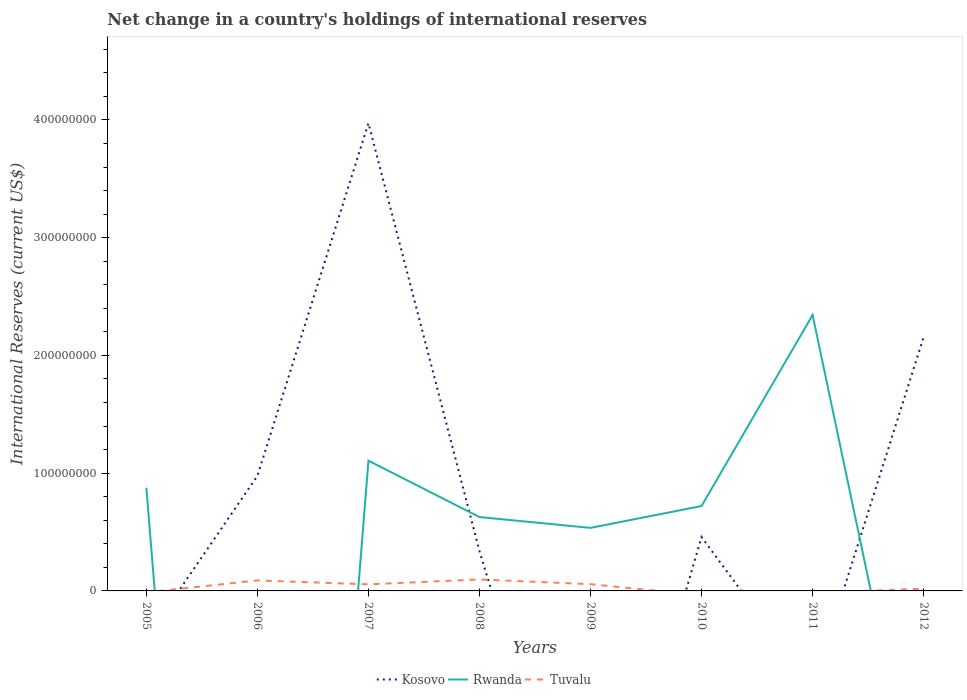Is the number of lines equal to the number of legend labels?
Provide a short and direct response. No. Across all years, what is the maximum international reserves in Kosovo?
Give a very brief answer. 0. What is the total international reserves in Rwanda in the graph?
Your response must be concise. -1.81e+08. What is the difference between the highest and the second highest international reserves in Kosovo?
Your response must be concise. 3.97e+08. What is the difference between the highest and the lowest international reserves in Kosovo?
Ensure brevity in your answer.  2. Is the international reserves in Tuvalu strictly greater than the international reserves in Rwanda over the years?
Offer a very short reply. No. How many years are there in the graph?
Offer a terse response. 8. What is the difference between two consecutive major ticks on the Y-axis?
Provide a short and direct response. 1.00e+08. Are the values on the major ticks of Y-axis written in scientific E-notation?
Offer a terse response. No. How many legend labels are there?
Offer a very short reply. 3. How are the legend labels stacked?
Your answer should be compact. Horizontal. What is the title of the graph?
Your answer should be compact. Net change in a country's holdings of international reserves. What is the label or title of the Y-axis?
Give a very brief answer. International Reserves (current US$). What is the International Reserves (current US$) in Rwanda in 2005?
Your answer should be compact. 8.77e+07. What is the International Reserves (current US$) in Tuvalu in 2005?
Your answer should be compact. 0. What is the International Reserves (current US$) in Kosovo in 2006?
Ensure brevity in your answer.  9.77e+07. What is the International Reserves (current US$) in Tuvalu in 2006?
Provide a succinct answer. 8.93e+06. What is the International Reserves (current US$) of Kosovo in 2007?
Offer a terse response. 3.97e+08. What is the International Reserves (current US$) of Rwanda in 2007?
Provide a short and direct response. 1.11e+08. What is the International Reserves (current US$) in Tuvalu in 2007?
Provide a succinct answer. 5.58e+06. What is the International Reserves (current US$) in Kosovo in 2008?
Give a very brief answer. 3.38e+07. What is the International Reserves (current US$) in Rwanda in 2008?
Provide a succinct answer. 6.27e+07. What is the International Reserves (current US$) of Tuvalu in 2008?
Your answer should be very brief. 9.75e+06. What is the International Reserves (current US$) of Rwanda in 2009?
Give a very brief answer. 5.35e+07. What is the International Reserves (current US$) of Tuvalu in 2009?
Offer a terse response. 5.74e+06. What is the International Reserves (current US$) of Kosovo in 2010?
Keep it short and to the point. 4.57e+07. What is the International Reserves (current US$) in Rwanda in 2010?
Make the answer very short. 7.21e+07. What is the International Reserves (current US$) in Kosovo in 2011?
Provide a succinct answer. 0. What is the International Reserves (current US$) of Rwanda in 2011?
Keep it short and to the point. 2.34e+08. What is the International Reserves (current US$) of Tuvalu in 2011?
Keep it short and to the point. 0. What is the International Reserves (current US$) in Kosovo in 2012?
Provide a succinct answer. 2.16e+08. What is the International Reserves (current US$) of Tuvalu in 2012?
Give a very brief answer. 1.95e+06. Across all years, what is the maximum International Reserves (current US$) of Kosovo?
Provide a short and direct response. 3.97e+08. Across all years, what is the maximum International Reserves (current US$) of Rwanda?
Make the answer very short. 2.34e+08. Across all years, what is the maximum International Reserves (current US$) of Tuvalu?
Your answer should be very brief. 9.75e+06. Across all years, what is the minimum International Reserves (current US$) of Kosovo?
Keep it short and to the point. 0. What is the total International Reserves (current US$) of Kosovo in the graph?
Ensure brevity in your answer.  7.90e+08. What is the total International Reserves (current US$) in Rwanda in the graph?
Keep it short and to the point. 6.21e+08. What is the total International Reserves (current US$) in Tuvalu in the graph?
Give a very brief answer. 3.19e+07. What is the difference between the International Reserves (current US$) in Rwanda in 2005 and that in 2007?
Keep it short and to the point. -2.29e+07. What is the difference between the International Reserves (current US$) of Rwanda in 2005 and that in 2008?
Provide a succinct answer. 2.50e+07. What is the difference between the International Reserves (current US$) in Rwanda in 2005 and that in 2009?
Provide a succinct answer. 3.41e+07. What is the difference between the International Reserves (current US$) of Rwanda in 2005 and that in 2010?
Offer a very short reply. 1.56e+07. What is the difference between the International Reserves (current US$) in Rwanda in 2005 and that in 2011?
Ensure brevity in your answer.  -1.47e+08. What is the difference between the International Reserves (current US$) of Kosovo in 2006 and that in 2007?
Your response must be concise. -3.00e+08. What is the difference between the International Reserves (current US$) of Tuvalu in 2006 and that in 2007?
Provide a succinct answer. 3.34e+06. What is the difference between the International Reserves (current US$) of Kosovo in 2006 and that in 2008?
Your answer should be compact. 6.39e+07. What is the difference between the International Reserves (current US$) in Tuvalu in 2006 and that in 2008?
Provide a short and direct response. -8.27e+05. What is the difference between the International Reserves (current US$) of Tuvalu in 2006 and that in 2009?
Your answer should be very brief. 3.19e+06. What is the difference between the International Reserves (current US$) of Kosovo in 2006 and that in 2010?
Offer a very short reply. 5.20e+07. What is the difference between the International Reserves (current US$) of Kosovo in 2006 and that in 2012?
Your answer should be compact. -1.18e+08. What is the difference between the International Reserves (current US$) in Tuvalu in 2006 and that in 2012?
Provide a short and direct response. 6.97e+06. What is the difference between the International Reserves (current US$) in Kosovo in 2007 and that in 2008?
Offer a very short reply. 3.63e+08. What is the difference between the International Reserves (current US$) of Rwanda in 2007 and that in 2008?
Offer a very short reply. 4.79e+07. What is the difference between the International Reserves (current US$) in Tuvalu in 2007 and that in 2008?
Give a very brief answer. -4.17e+06. What is the difference between the International Reserves (current US$) of Rwanda in 2007 and that in 2009?
Provide a short and direct response. 5.71e+07. What is the difference between the International Reserves (current US$) in Tuvalu in 2007 and that in 2009?
Give a very brief answer. -1.52e+05. What is the difference between the International Reserves (current US$) in Kosovo in 2007 and that in 2010?
Your response must be concise. 3.52e+08. What is the difference between the International Reserves (current US$) of Rwanda in 2007 and that in 2010?
Make the answer very short. 3.85e+07. What is the difference between the International Reserves (current US$) of Rwanda in 2007 and that in 2011?
Keep it short and to the point. -1.24e+08. What is the difference between the International Reserves (current US$) in Kosovo in 2007 and that in 2012?
Provide a succinct answer. 1.82e+08. What is the difference between the International Reserves (current US$) of Tuvalu in 2007 and that in 2012?
Provide a succinct answer. 3.63e+06. What is the difference between the International Reserves (current US$) in Rwanda in 2008 and that in 2009?
Offer a terse response. 9.17e+06. What is the difference between the International Reserves (current US$) of Tuvalu in 2008 and that in 2009?
Make the answer very short. 4.02e+06. What is the difference between the International Reserves (current US$) of Kosovo in 2008 and that in 2010?
Give a very brief answer. -1.19e+07. What is the difference between the International Reserves (current US$) of Rwanda in 2008 and that in 2010?
Provide a short and direct response. -9.38e+06. What is the difference between the International Reserves (current US$) in Rwanda in 2008 and that in 2011?
Offer a very short reply. -1.72e+08. What is the difference between the International Reserves (current US$) in Kosovo in 2008 and that in 2012?
Your answer should be compact. -1.82e+08. What is the difference between the International Reserves (current US$) of Tuvalu in 2008 and that in 2012?
Your response must be concise. 7.80e+06. What is the difference between the International Reserves (current US$) in Rwanda in 2009 and that in 2010?
Your answer should be compact. -1.85e+07. What is the difference between the International Reserves (current US$) of Rwanda in 2009 and that in 2011?
Give a very brief answer. -1.81e+08. What is the difference between the International Reserves (current US$) of Tuvalu in 2009 and that in 2012?
Your answer should be very brief. 3.79e+06. What is the difference between the International Reserves (current US$) of Rwanda in 2010 and that in 2011?
Ensure brevity in your answer.  -1.62e+08. What is the difference between the International Reserves (current US$) in Kosovo in 2010 and that in 2012?
Your answer should be compact. -1.70e+08. What is the difference between the International Reserves (current US$) in Rwanda in 2005 and the International Reserves (current US$) in Tuvalu in 2006?
Provide a succinct answer. 7.88e+07. What is the difference between the International Reserves (current US$) in Rwanda in 2005 and the International Reserves (current US$) in Tuvalu in 2007?
Your response must be concise. 8.21e+07. What is the difference between the International Reserves (current US$) of Rwanda in 2005 and the International Reserves (current US$) of Tuvalu in 2008?
Give a very brief answer. 7.79e+07. What is the difference between the International Reserves (current US$) of Rwanda in 2005 and the International Reserves (current US$) of Tuvalu in 2009?
Provide a succinct answer. 8.19e+07. What is the difference between the International Reserves (current US$) of Rwanda in 2005 and the International Reserves (current US$) of Tuvalu in 2012?
Ensure brevity in your answer.  8.57e+07. What is the difference between the International Reserves (current US$) of Kosovo in 2006 and the International Reserves (current US$) of Rwanda in 2007?
Give a very brief answer. -1.29e+07. What is the difference between the International Reserves (current US$) of Kosovo in 2006 and the International Reserves (current US$) of Tuvalu in 2007?
Your answer should be very brief. 9.21e+07. What is the difference between the International Reserves (current US$) of Kosovo in 2006 and the International Reserves (current US$) of Rwanda in 2008?
Your response must be concise. 3.50e+07. What is the difference between the International Reserves (current US$) in Kosovo in 2006 and the International Reserves (current US$) in Tuvalu in 2008?
Ensure brevity in your answer.  8.79e+07. What is the difference between the International Reserves (current US$) of Kosovo in 2006 and the International Reserves (current US$) of Rwanda in 2009?
Ensure brevity in your answer.  4.41e+07. What is the difference between the International Reserves (current US$) of Kosovo in 2006 and the International Reserves (current US$) of Tuvalu in 2009?
Your answer should be very brief. 9.20e+07. What is the difference between the International Reserves (current US$) in Kosovo in 2006 and the International Reserves (current US$) in Rwanda in 2010?
Make the answer very short. 2.56e+07. What is the difference between the International Reserves (current US$) of Kosovo in 2006 and the International Reserves (current US$) of Rwanda in 2011?
Offer a terse response. -1.37e+08. What is the difference between the International Reserves (current US$) of Kosovo in 2006 and the International Reserves (current US$) of Tuvalu in 2012?
Ensure brevity in your answer.  9.57e+07. What is the difference between the International Reserves (current US$) of Kosovo in 2007 and the International Reserves (current US$) of Rwanda in 2008?
Provide a short and direct response. 3.35e+08. What is the difference between the International Reserves (current US$) in Kosovo in 2007 and the International Reserves (current US$) in Tuvalu in 2008?
Keep it short and to the point. 3.88e+08. What is the difference between the International Reserves (current US$) in Rwanda in 2007 and the International Reserves (current US$) in Tuvalu in 2008?
Your answer should be very brief. 1.01e+08. What is the difference between the International Reserves (current US$) of Kosovo in 2007 and the International Reserves (current US$) of Rwanda in 2009?
Make the answer very short. 3.44e+08. What is the difference between the International Reserves (current US$) of Kosovo in 2007 and the International Reserves (current US$) of Tuvalu in 2009?
Your answer should be very brief. 3.92e+08. What is the difference between the International Reserves (current US$) in Rwanda in 2007 and the International Reserves (current US$) in Tuvalu in 2009?
Offer a terse response. 1.05e+08. What is the difference between the International Reserves (current US$) in Kosovo in 2007 and the International Reserves (current US$) in Rwanda in 2010?
Your response must be concise. 3.25e+08. What is the difference between the International Reserves (current US$) of Kosovo in 2007 and the International Reserves (current US$) of Rwanda in 2011?
Offer a terse response. 1.63e+08. What is the difference between the International Reserves (current US$) of Kosovo in 2007 and the International Reserves (current US$) of Tuvalu in 2012?
Your answer should be very brief. 3.95e+08. What is the difference between the International Reserves (current US$) of Rwanda in 2007 and the International Reserves (current US$) of Tuvalu in 2012?
Make the answer very short. 1.09e+08. What is the difference between the International Reserves (current US$) of Kosovo in 2008 and the International Reserves (current US$) of Rwanda in 2009?
Ensure brevity in your answer.  -1.97e+07. What is the difference between the International Reserves (current US$) in Kosovo in 2008 and the International Reserves (current US$) in Tuvalu in 2009?
Provide a short and direct response. 2.81e+07. What is the difference between the International Reserves (current US$) of Rwanda in 2008 and the International Reserves (current US$) of Tuvalu in 2009?
Give a very brief answer. 5.70e+07. What is the difference between the International Reserves (current US$) of Kosovo in 2008 and the International Reserves (current US$) of Rwanda in 2010?
Your answer should be very brief. -3.83e+07. What is the difference between the International Reserves (current US$) in Kosovo in 2008 and the International Reserves (current US$) in Rwanda in 2011?
Your response must be concise. -2.01e+08. What is the difference between the International Reserves (current US$) in Kosovo in 2008 and the International Reserves (current US$) in Tuvalu in 2012?
Provide a succinct answer. 3.19e+07. What is the difference between the International Reserves (current US$) of Rwanda in 2008 and the International Reserves (current US$) of Tuvalu in 2012?
Your response must be concise. 6.08e+07. What is the difference between the International Reserves (current US$) in Rwanda in 2009 and the International Reserves (current US$) in Tuvalu in 2012?
Provide a short and direct response. 5.16e+07. What is the difference between the International Reserves (current US$) of Kosovo in 2010 and the International Reserves (current US$) of Rwanda in 2011?
Make the answer very short. -1.89e+08. What is the difference between the International Reserves (current US$) of Kosovo in 2010 and the International Reserves (current US$) of Tuvalu in 2012?
Offer a terse response. 4.38e+07. What is the difference between the International Reserves (current US$) of Rwanda in 2010 and the International Reserves (current US$) of Tuvalu in 2012?
Make the answer very short. 7.01e+07. What is the difference between the International Reserves (current US$) in Rwanda in 2011 and the International Reserves (current US$) in Tuvalu in 2012?
Offer a terse response. 2.32e+08. What is the average International Reserves (current US$) in Kosovo per year?
Keep it short and to the point. 9.88e+07. What is the average International Reserves (current US$) in Rwanda per year?
Your answer should be compact. 7.76e+07. What is the average International Reserves (current US$) of Tuvalu per year?
Your response must be concise. 3.99e+06. In the year 2006, what is the difference between the International Reserves (current US$) of Kosovo and International Reserves (current US$) of Tuvalu?
Keep it short and to the point. 8.88e+07. In the year 2007, what is the difference between the International Reserves (current US$) of Kosovo and International Reserves (current US$) of Rwanda?
Provide a succinct answer. 2.87e+08. In the year 2007, what is the difference between the International Reserves (current US$) in Kosovo and International Reserves (current US$) in Tuvalu?
Provide a short and direct response. 3.92e+08. In the year 2007, what is the difference between the International Reserves (current US$) of Rwanda and International Reserves (current US$) of Tuvalu?
Provide a succinct answer. 1.05e+08. In the year 2008, what is the difference between the International Reserves (current US$) of Kosovo and International Reserves (current US$) of Rwanda?
Provide a short and direct response. -2.89e+07. In the year 2008, what is the difference between the International Reserves (current US$) of Kosovo and International Reserves (current US$) of Tuvalu?
Keep it short and to the point. 2.41e+07. In the year 2008, what is the difference between the International Reserves (current US$) in Rwanda and International Reserves (current US$) in Tuvalu?
Keep it short and to the point. 5.30e+07. In the year 2009, what is the difference between the International Reserves (current US$) of Rwanda and International Reserves (current US$) of Tuvalu?
Give a very brief answer. 4.78e+07. In the year 2010, what is the difference between the International Reserves (current US$) in Kosovo and International Reserves (current US$) in Rwanda?
Your answer should be compact. -2.64e+07. In the year 2012, what is the difference between the International Reserves (current US$) in Kosovo and International Reserves (current US$) in Tuvalu?
Provide a short and direct response. 2.14e+08. What is the ratio of the International Reserves (current US$) of Rwanda in 2005 to that in 2007?
Provide a succinct answer. 0.79. What is the ratio of the International Reserves (current US$) in Rwanda in 2005 to that in 2008?
Provide a succinct answer. 1.4. What is the ratio of the International Reserves (current US$) in Rwanda in 2005 to that in 2009?
Offer a very short reply. 1.64. What is the ratio of the International Reserves (current US$) in Rwanda in 2005 to that in 2010?
Your answer should be very brief. 1.22. What is the ratio of the International Reserves (current US$) of Rwanda in 2005 to that in 2011?
Your answer should be compact. 0.37. What is the ratio of the International Reserves (current US$) of Kosovo in 2006 to that in 2007?
Your answer should be compact. 0.25. What is the ratio of the International Reserves (current US$) in Tuvalu in 2006 to that in 2007?
Offer a terse response. 1.6. What is the ratio of the International Reserves (current US$) in Kosovo in 2006 to that in 2008?
Make the answer very short. 2.89. What is the ratio of the International Reserves (current US$) in Tuvalu in 2006 to that in 2008?
Your answer should be compact. 0.92. What is the ratio of the International Reserves (current US$) in Tuvalu in 2006 to that in 2009?
Your answer should be compact. 1.56. What is the ratio of the International Reserves (current US$) in Kosovo in 2006 to that in 2010?
Ensure brevity in your answer.  2.14. What is the ratio of the International Reserves (current US$) in Kosovo in 2006 to that in 2012?
Give a very brief answer. 0.45. What is the ratio of the International Reserves (current US$) of Tuvalu in 2006 to that in 2012?
Your answer should be compact. 4.58. What is the ratio of the International Reserves (current US$) in Kosovo in 2007 to that in 2008?
Provide a succinct answer. 11.75. What is the ratio of the International Reserves (current US$) of Rwanda in 2007 to that in 2008?
Provide a short and direct response. 1.76. What is the ratio of the International Reserves (current US$) in Tuvalu in 2007 to that in 2008?
Make the answer very short. 0.57. What is the ratio of the International Reserves (current US$) in Rwanda in 2007 to that in 2009?
Your answer should be very brief. 2.07. What is the ratio of the International Reserves (current US$) of Tuvalu in 2007 to that in 2009?
Ensure brevity in your answer.  0.97. What is the ratio of the International Reserves (current US$) of Kosovo in 2007 to that in 2010?
Your answer should be very brief. 8.69. What is the ratio of the International Reserves (current US$) of Rwanda in 2007 to that in 2010?
Provide a succinct answer. 1.53. What is the ratio of the International Reserves (current US$) of Rwanda in 2007 to that in 2011?
Keep it short and to the point. 0.47. What is the ratio of the International Reserves (current US$) of Kosovo in 2007 to that in 2012?
Offer a terse response. 1.84. What is the ratio of the International Reserves (current US$) of Tuvalu in 2007 to that in 2012?
Your response must be concise. 2.86. What is the ratio of the International Reserves (current US$) of Rwanda in 2008 to that in 2009?
Offer a terse response. 1.17. What is the ratio of the International Reserves (current US$) of Tuvalu in 2008 to that in 2009?
Your answer should be compact. 1.7. What is the ratio of the International Reserves (current US$) of Kosovo in 2008 to that in 2010?
Provide a short and direct response. 0.74. What is the ratio of the International Reserves (current US$) in Rwanda in 2008 to that in 2010?
Provide a short and direct response. 0.87. What is the ratio of the International Reserves (current US$) in Rwanda in 2008 to that in 2011?
Ensure brevity in your answer.  0.27. What is the ratio of the International Reserves (current US$) of Kosovo in 2008 to that in 2012?
Your answer should be very brief. 0.16. What is the ratio of the International Reserves (current US$) of Rwanda in 2009 to that in 2010?
Give a very brief answer. 0.74. What is the ratio of the International Reserves (current US$) in Rwanda in 2009 to that in 2011?
Ensure brevity in your answer.  0.23. What is the ratio of the International Reserves (current US$) of Tuvalu in 2009 to that in 2012?
Ensure brevity in your answer.  2.94. What is the ratio of the International Reserves (current US$) of Rwanda in 2010 to that in 2011?
Your answer should be very brief. 0.31. What is the ratio of the International Reserves (current US$) in Kosovo in 2010 to that in 2012?
Keep it short and to the point. 0.21. What is the difference between the highest and the second highest International Reserves (current US$) in Kosovo?
Keep it short and to the point. 1.82e+08. What is the difference between the highest and the second highest International Reserves (current US$) in Rwanda?
Ensure brevity in your answer.  1.24e+08. What is the difference between the highest and the second highest International Reserves (current US$) of Tuvalu?
Offer a terse response. 8.27e+05. What is the difference between the highest and the lowest International Reserves (current US$) in Kosovo?
Give a very brief answer. 3.97e+08. What is the difference between the highest and the lowest International Reserves (current US$) of Rwanda?
Give a very brief answer. 2.34e+08. What is the difference between the highest and the lowest International Reserves (current US$) in Tuvalu?
Offer a very short reply. 9.75e+06. 